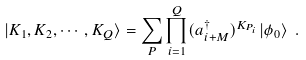<formula> <loc_0><loc_0><loc_500><loc_500>| K _ { 1 } , K _ { 2 } , \cdots , K _ { Q } \rangle = \sum _ { P } \prod _ { i = 1 } ^ { Q } ( a _ { i + M } ^ { \dagger } ) ^ { K _ { P _ { i } } } | \phi _ { 0 } \rangle \ .</formula> 